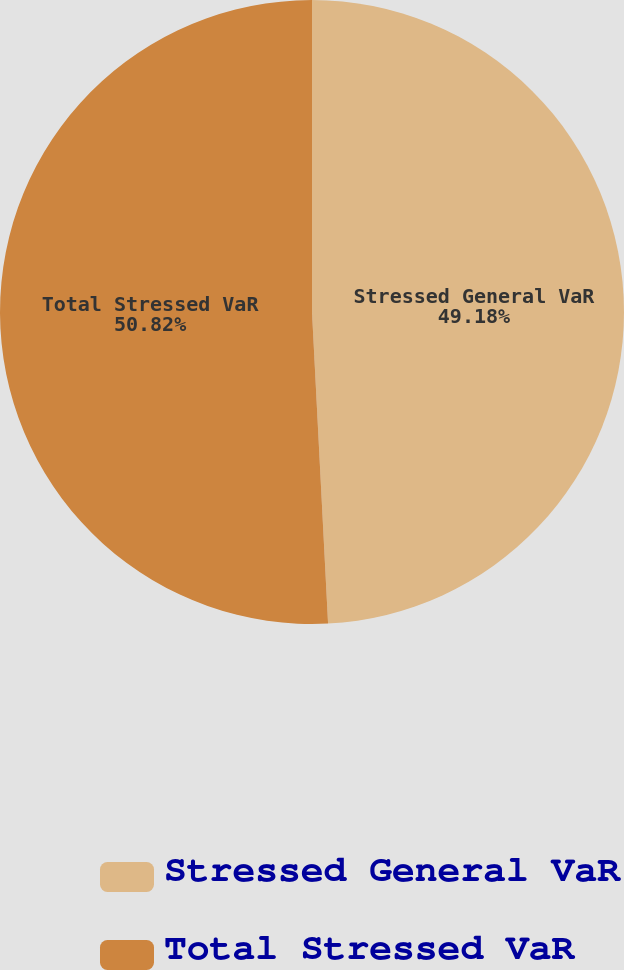Convert chart. <chart><loc_0><loc_0><loc_500><loc_500><pie_chart><fcel>Stressed General VaR<fcel>Total Stressed VaR<nl><fcel>49.18%<fcel>50.82%<nl></chart> 